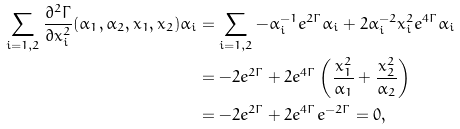<formula> <loc_0><loc_0><loc_500><loc_500>\sum _ { i = 1 , 2 } \frac { \partial ^ { 2 } \Gamma } { \partial x _ { i } ^ { 2 } } ( \alpha _ { 1 } , \alpha _ { 2 } , x _ { 1 } , x _ { 2 } ) \alpha _ { i } & = \sum _ { i = 1 , 2 } - \alpha _ { i } ^ { - 1 } e ^ { 2 \Gamma } \alpha _ { i } + 2 \alpha _ { i } ^ { - 2 } x _ { i } ^ { 2 } e ^ { 4 \Gamma } \alpha _ { i } \\ & = - 2 e ^ { 2 \Gamma } + 2 e ^ { 4 \Gamma } \left ( \frac { x _ { 1 } ^ { 2 } } { \alpha _ { 1 } } + \frac { x _ { 2 } ^ { 2 } } { \alpha _ { 2 } } \right ) \\ & = - 2 e ^ { 2 \Gamma } + 2 e ^ { 4 \Gamma } e ^ { - 2 \Gamma } = 0 ,</formula> 